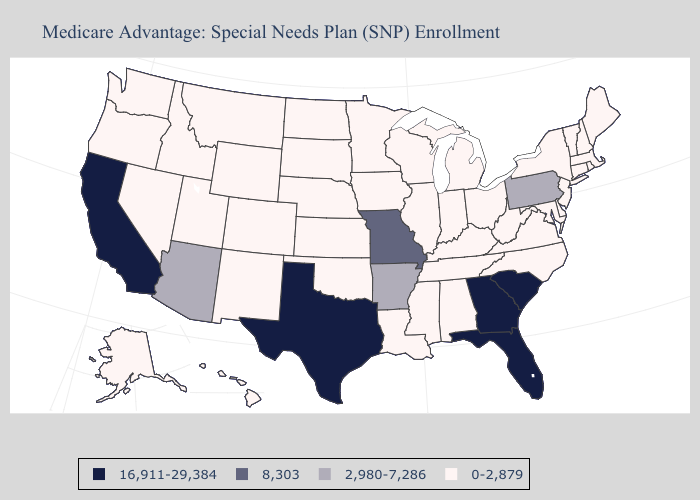Which states hav the highest value in the MidWest?
Short answer required. Missouri. Does South Dakota have the highest value in the MidWest?
Give a very brief answer. No. What is the lowest value in states that border Georgia?
Quick response, please. 0-2,879. What is the value of Wisconsin?
Be succinct. 0-2,879. What is the value of North Dakota?
Keep it brief. 0-2,879. Does the map have missing data?
Concise answer only. No. What is the value of Delaware?
Short answer required. 0-2,879. Among the states that border Utah , does Arizona have the lowest value?
Write a very short answer. No. Name the states that have a value in the range 2,980-7,286?
Give a very brief answer. Arkansas, Arizona, Pennsylvania. Among the states that border Oklahoma , which have the lowest value?
Answer briefly. Colorado, Kansas, New Mexico. Is the legend a continuous bar?
Keep it brief. No. Does Oregon have the same value as Wyoming?
Give a very brief answer. Yes. Does Vermont have the same value as Texas?
Be succinct. No. Among the states that border Georgia , does Tennessee have the lowest value?
Quick response, please. Yes. 